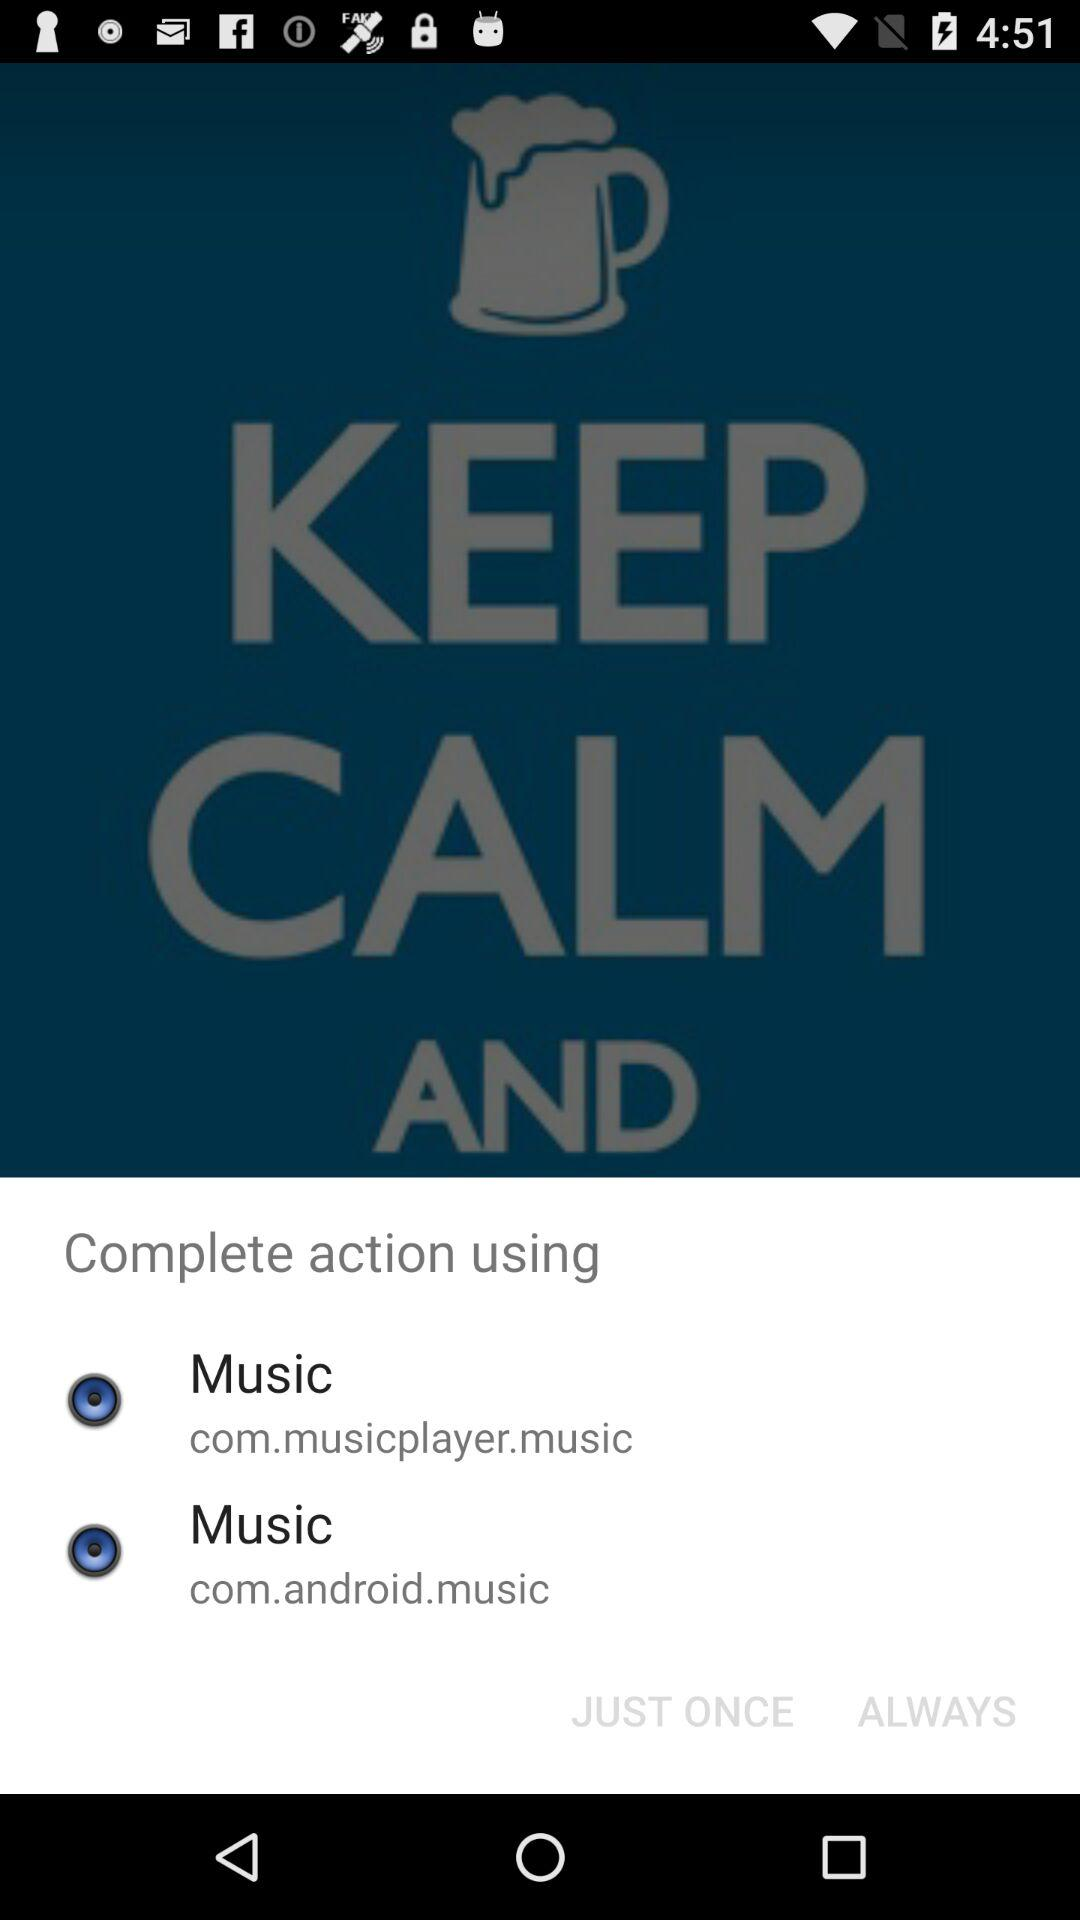Which application can be used to complete the action? The application "Music" can be used to complete the action. 